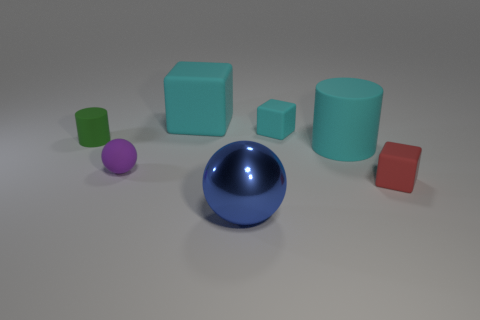What color is the large thing that is the same shape as the tiny purple matte thing? The large object that shares its shape with the small purple matte one is blue, exhibiting a glossy finish which distinguishes it from the matte texture of the smaller object. 